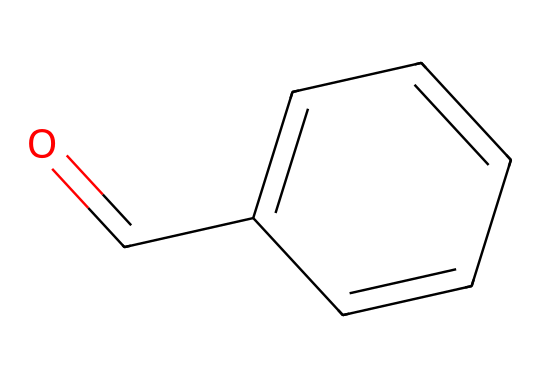What is the chemical name of this compound? The SMILES representation corresponds to benzaldehyde, which is evident from the functional group (aldehyde) indicated by 'O=C' and the phenyl ring structure shown in 'c1ccccc1'.
Answer: benzaldehyde How many carbon atoms are present in this structure? Analyzing the SMILES representation, 'c1ccccc1' indicates a 6-carbon aromatic ring, and 'O=C' adds 1 more carbon for a total of 7 carbon atoms.
Answer: 7 What type of functional group is present in benzaldehyde? The 'O=C' portion of the SMILES indicates that the compound contains an aldehyde functional group. Aldehydes are characterized by a carbonyl group (C=O) at the end of a carbon chain.
Answer: aldehyde Which structural feature contributes to the almond scent? The aromatic nature of the 6-membered carbon ring (benzene) combined with the aldehyde functional group 'O=C' is responsible for the characteristic almond-like scent of benzaldehyde. The aromaticity enhances the scent.
Answer: aromatic ring Does this compound exhibit aromaticity? Yes, benzaldehyde's structure contains a continuous cyclic structure of alternating double bonds in the carbon ring, which meets the conditions for aromaticity defined by Hückel's rule (4n + 2 π electrons).
Answer: yes What is the total number of hydrogen atoms in benzaldehyde? In the benzaldehyde structure, there are 5 hydrogen atoms attached to the benzene ring and 1 hydrogen attached to the carbonyl carbon, totaling 6 hydrogen atoms.
Answer: 6 